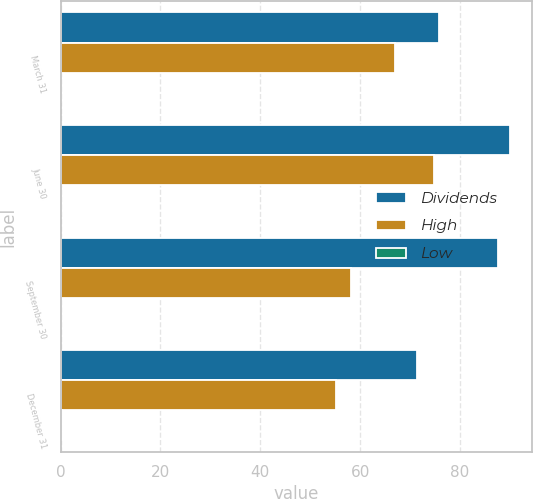Convert chart. <chart><loc_0><loc_0><loc_500><loc_500><stacked_bar_chart><ecel><fcel>March 31<fcel>June 30<fcel>September 30<fcel>December 31<nl><fcel>Dividends<fcel>75.73<fcel>90.01<fcel>87.54<fcel>71.33<nl><fcel>High<fcel>67.05<fcel>74.72<fcel>58.15<fcel>55.14<nl><fcel>Low<fcel>0.1<fcel>0.1<fcel>0.1<fcel>0.25<nl></chart> 